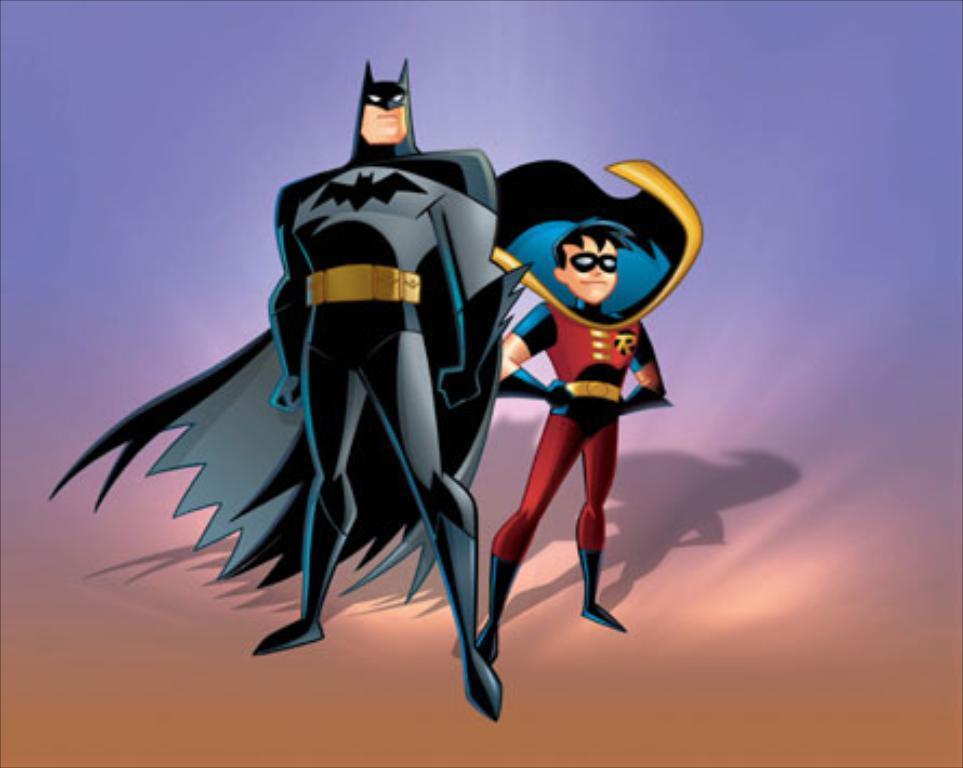Please provide a concise description of this image. This is an animated image. In this image we can see animated characters. 